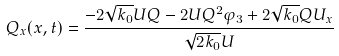<formula> <loc_0><loc_0><loc_500><loc_500>Q _ { x } ( x , t ) = \frac { - 2 \sqrt { k _ { 0 } } U Q - 2 U Q ^ { 2 } \varphi _ { 3 } + 2 \sqrt { k _ { 0 } } Q U _ { x } } { \sqrt { 2 k _ { 0 } } U }</formula> 